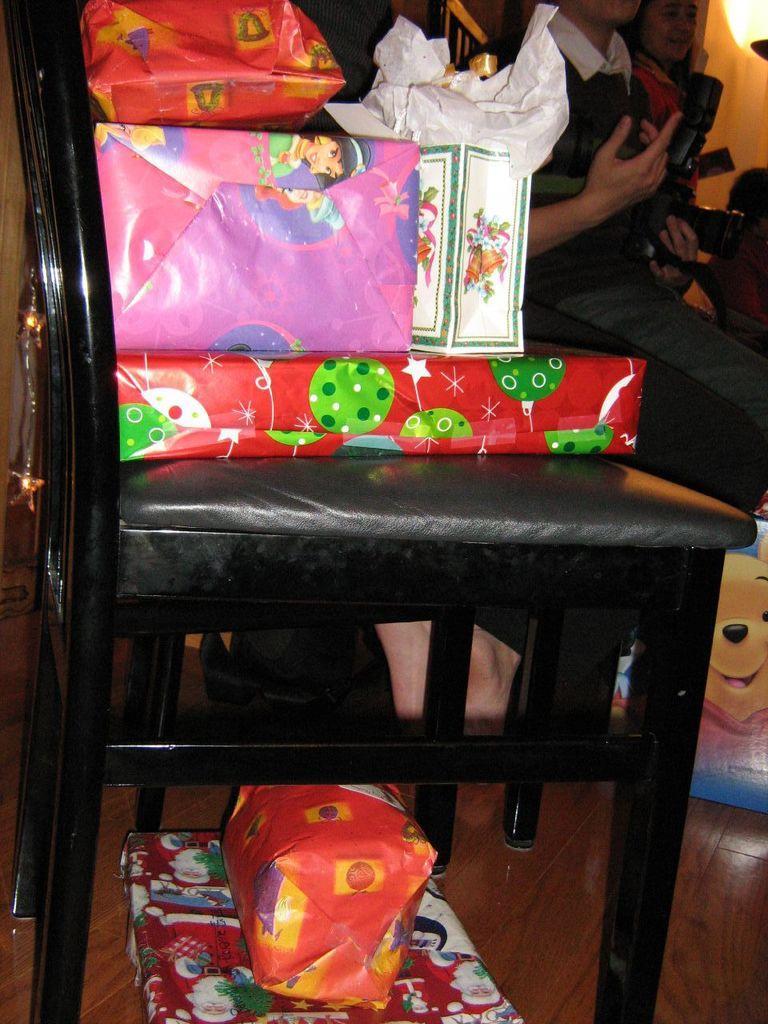How would you summarize this image in a sentence or two? In the image we can see chair,on chair we can see gift packets. In the background they were two persons sitting. And in the bottom we can see two more gift packets. 